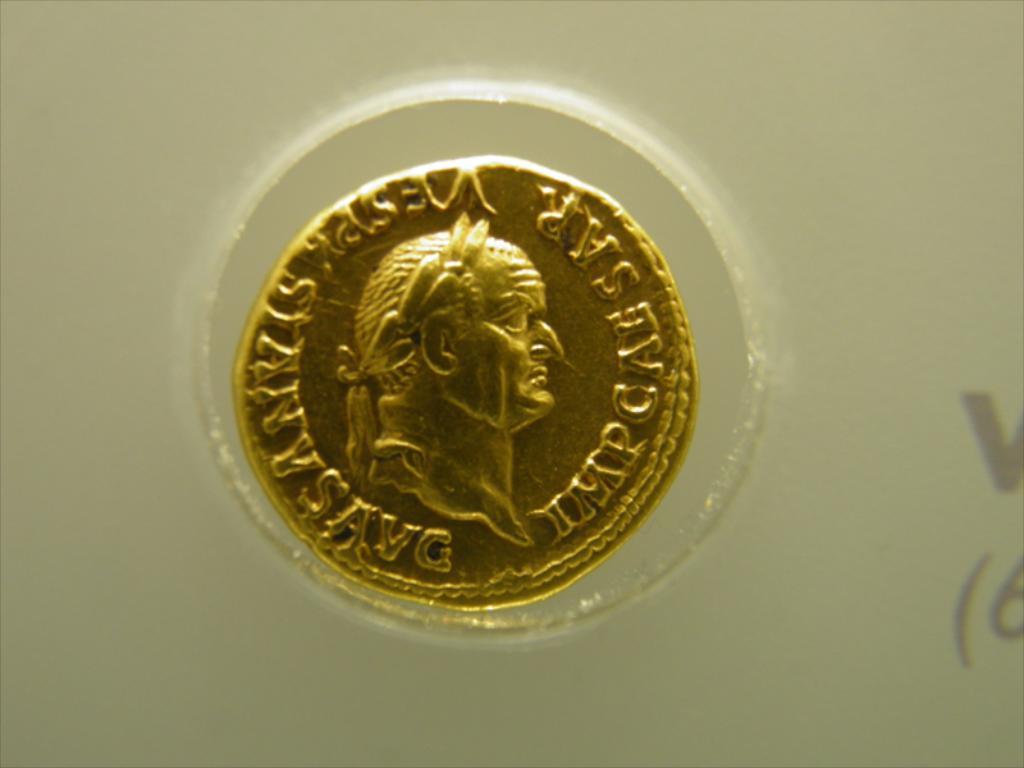Is this a coin for caeser?
Offer a very short reply. Yes. 